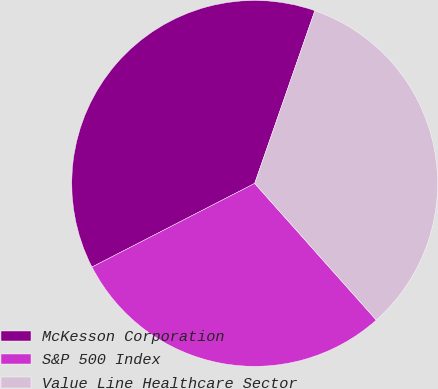Convert chart. <chart><loc_0><loc_0><loc_500><loc_500><pie_chart><fcel>McKesson Corporation<fcel>S&P 500 Index<fcel>Value Line Healthcare Sector<nl><fcel>37.89%<fcel>29.02%<fcel>33.09%<nl></chart> 